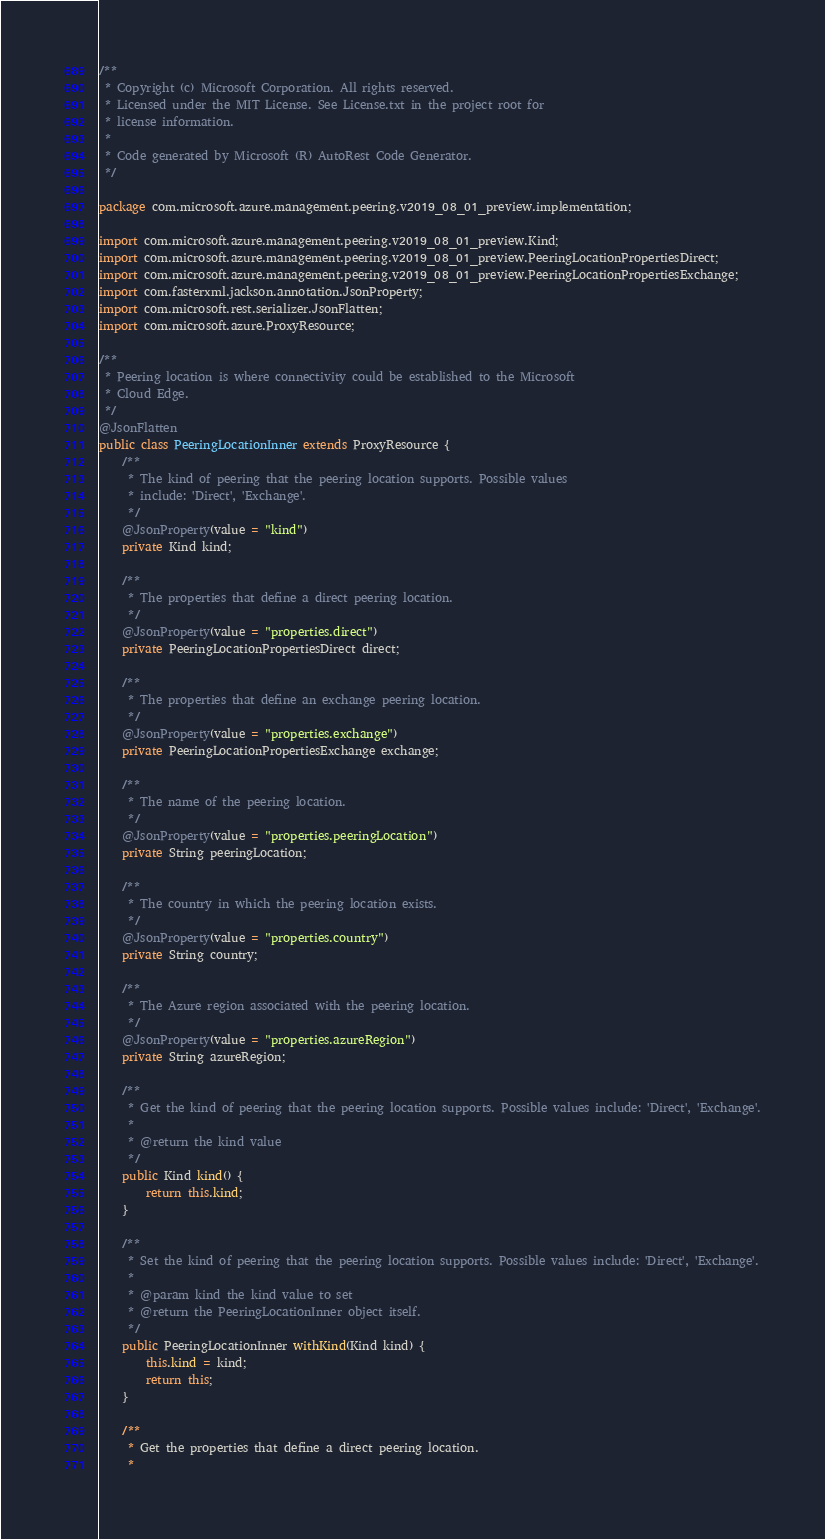<code> <loc_0><loc_0><loc_500><loc_500><_Java_>/**
 * Copyright (c) Microsoft Corporation. All rights reserved.
 * Licensed under the MIT License. See License.txt in the project root for
 * license information.
 *
 * Code generated by Microsoft (R) AutoRest Code Generator.
 */

package com.microsoft.azure.management.peering.v2019_08_01_preview.implementation;

import com.microsoft.azure.management.peering.v2019_08_01_preview.Kind;
import com.microsoft.azure.management.peering.v2019_08_01_preview.PeeringLocationPropertiesDirect;
import com.microsoft.azure.management.peering.v2019_08_01_preview.PeeringLocationPropertiesExchange;
import com.fasterxml.jackson.annotation.JsonProperty;
import com.microsoft.rest.serializer.JsonFlatten;
import com.microsoft.azure.ProxyResource;

/**
 * Peering location is where connectivity could be established to the Microsoft
 * Cloud Edge.
 */
@JsonFlatten
public class PeeringLocationInner extends ProxyResource {
    /**
     * The kind of peering that the peering location supports. Possible values
     * include: 'Direct', 'Exchange'.
     */
    @JsonProperty(value = "kind")
    private Kind kind;

    /**
     * The properties that define a direct peering location.
     */
    @JsonProperty(value = "properties.direct")
    private PeeringLocationPropertiesDirect direct;

    /**
     * The properties that define an exchange peering location.
     */
    @JsonProperty(value = "properties.exchange")
    private PeeringLocationPropertiesExchange exchange;

    /**
     * The name of the peering location.
     */
    @JsonProperty(value = "properties.peeringLocation")
    private String peeringLocation;

    /**
     * The country in which the peering location exists.
     */
    @JsonProperty(value = "properties.country")
    private String country;

    /**
     * The Azure region associated with the peering location.
     */
    @JsonProperty(value = "properties.azureRegion")
    private String azureRegion;

    /**
     * Get the kind of peering that the peering location supports. Possible values include: 'Direct', 'Exchange'.
     *
     * @return the kind value
     */
    public Kind kind() {
        return this.kind;
    }

    /**
     * Set the kind of peering that the peering location supports. Possible values include: 'Direct', 'Exchange'.
     *
     * @param kind the kind value to set
     * @return the PeeringLocationInner object itself.
     */
    public PeeringLocationInner withKind(Kind kind) {
        this.kind = kind;
        return this;
    }

    /**
     * Get the properties that define a direct peering location.
     *</code> 